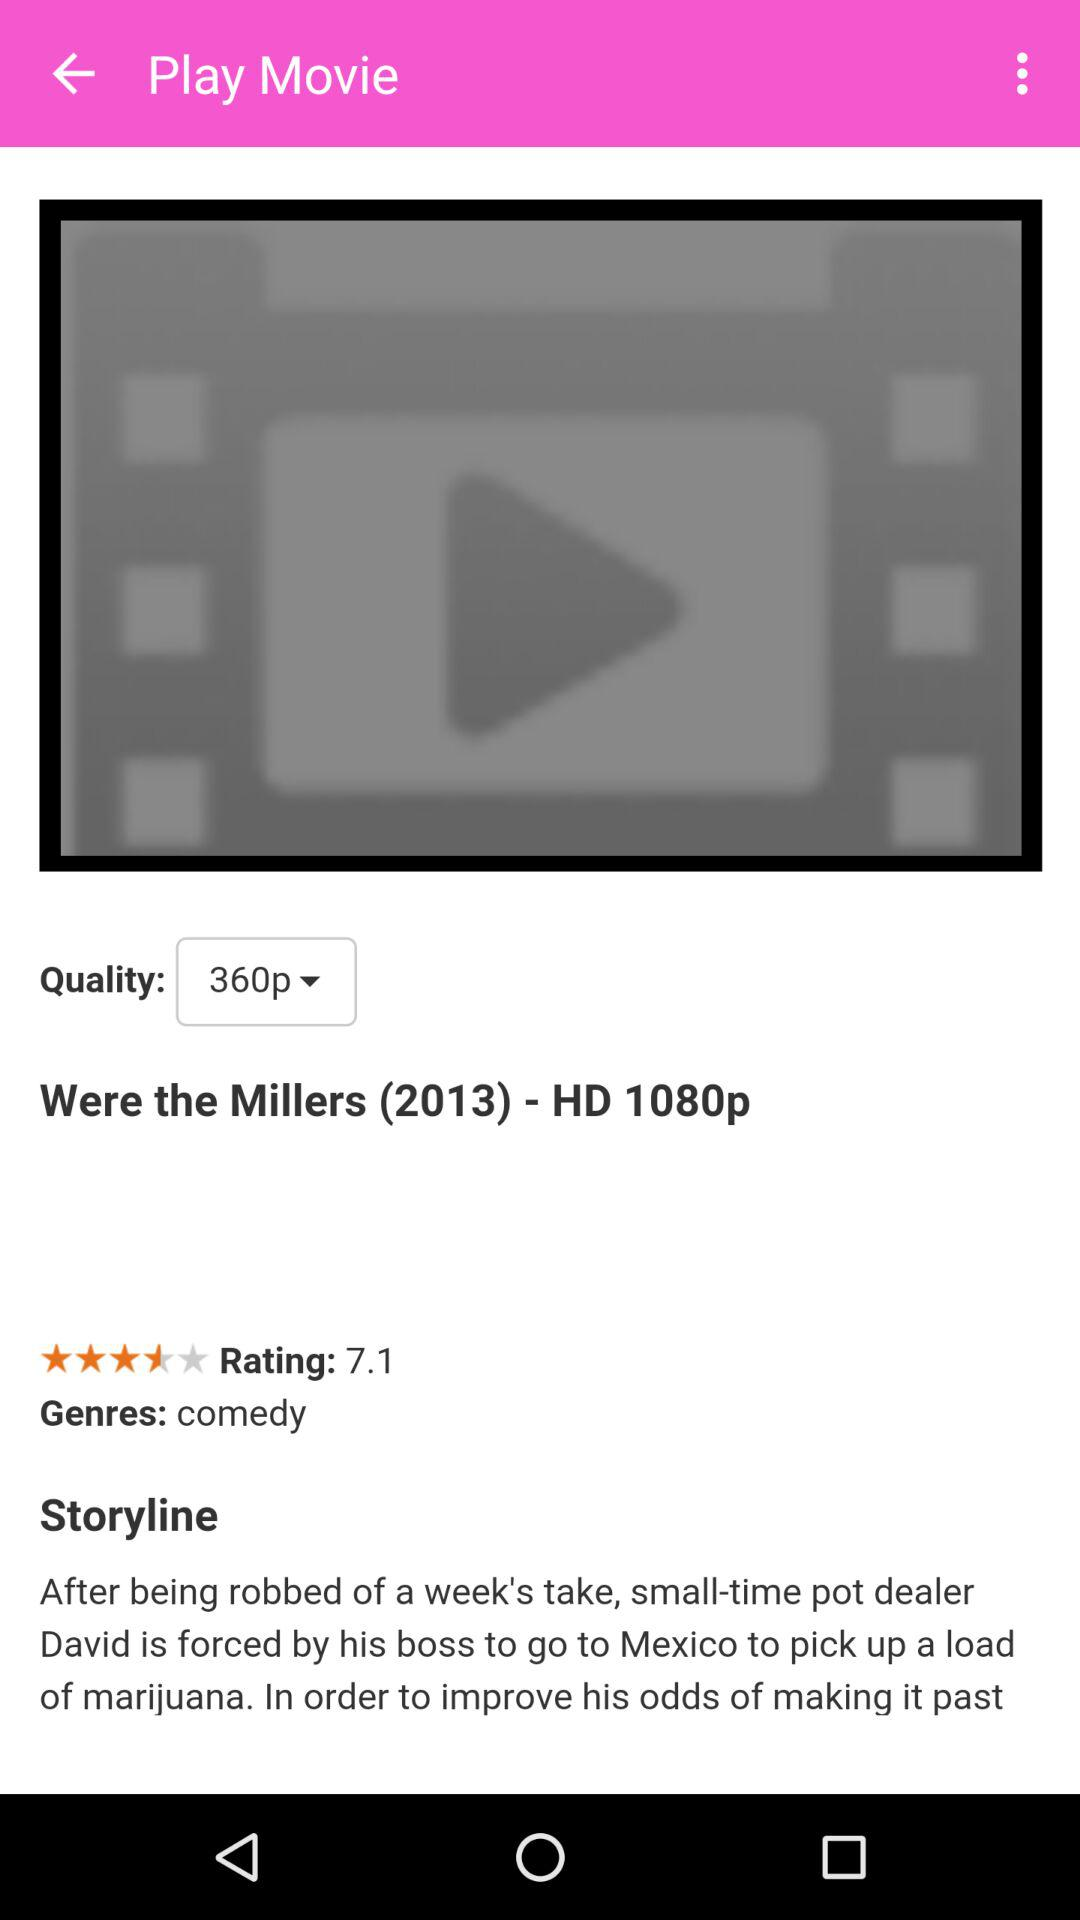What is the name of the movie? The name of the movie is "Were the Millers (2013)". 